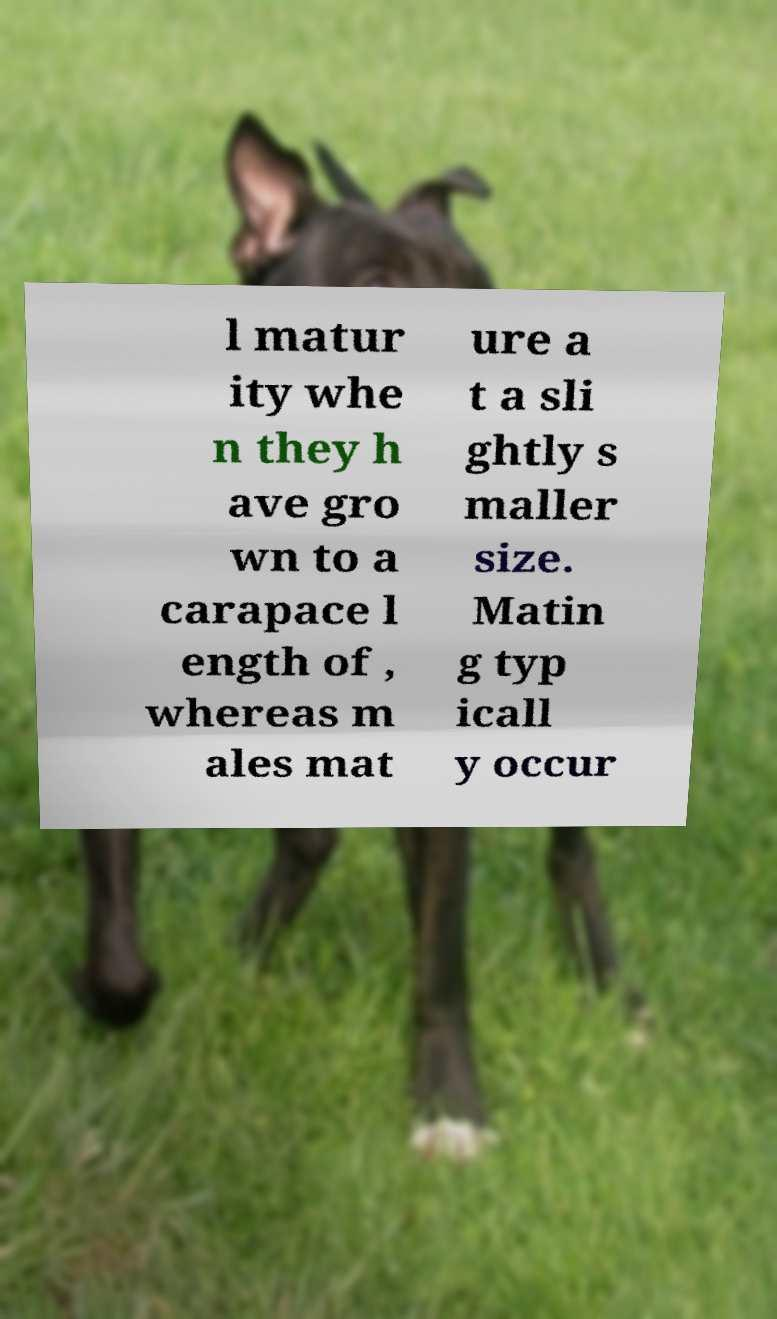For documentation purposes, I need the text within this image transcribed. Could you provide that? l matur ity whe n they h ave gro wn to a carapace l ength of , whereas m ales mat ure a t a sli ghtly s maller size. Matin g typ icall y occur 